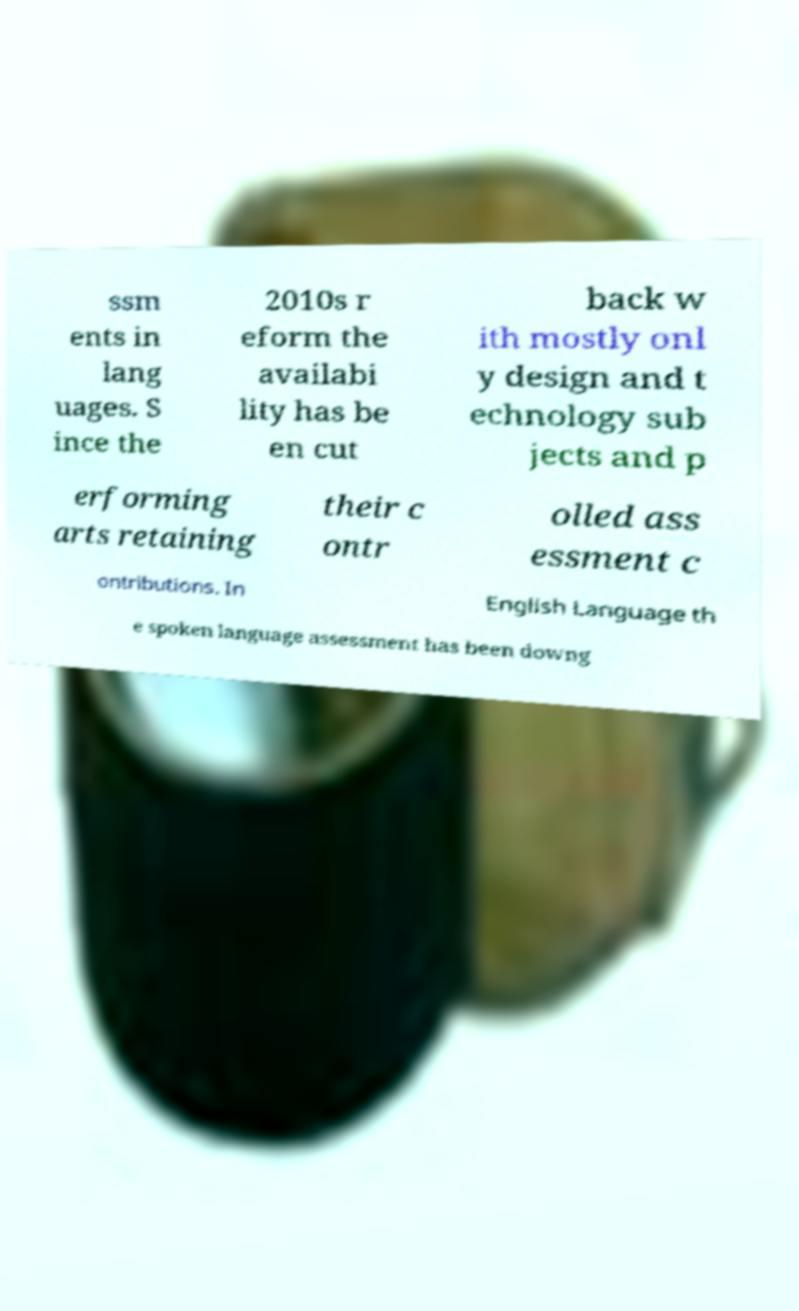Can you accurately transcribe the text from the provided image for me? ssm ents in lang uages. S ince the 2010s r eform the availabi lity has be en cut back w ith mostly onl y design and t echnology sub jects and p erforming arts retaining their c ontr olled ass essment c ontributions. In English Language th e spoken language assessment has been downg 